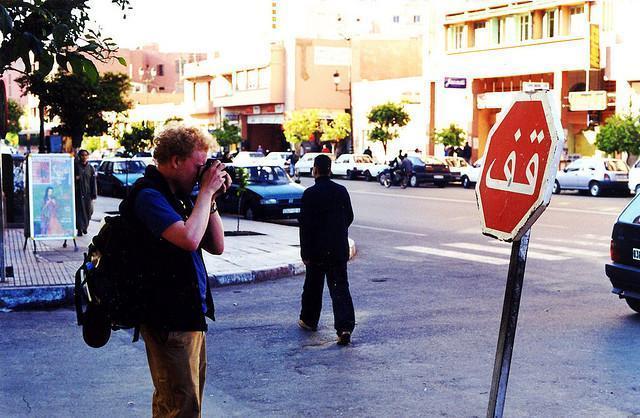How many people are in the photo?
Give a very brief answer. 2. How many cars are there?
Give a very brief answer. 3. 